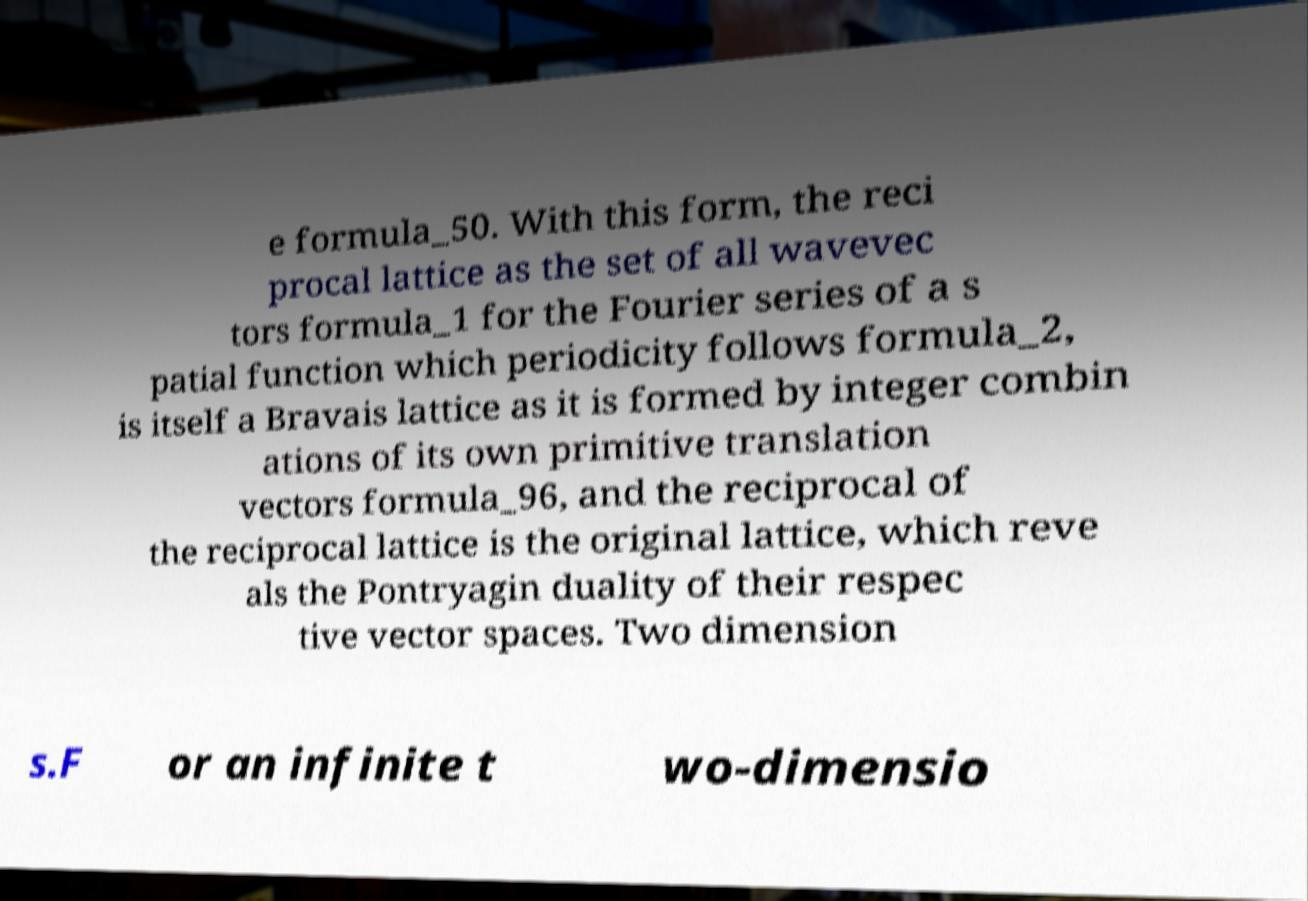Can you accurately transcribe the text from the provided image for me? e formula_50. With this form, the reci procal lattice as the set of all wavevec tors formula_1 for the Fourier series of a s patial function which periodicity follows formula_2, is itself a Bravais lattice as it is formed by integer combin ations of its own primitive translation vectors formula_96, and the reciprocal of the reciprocal lattice is the original lattice, which reve als the Pontryagin duality of their respec tive vector spaces. Two dimension s.F or an infinite t wo-dimensio 